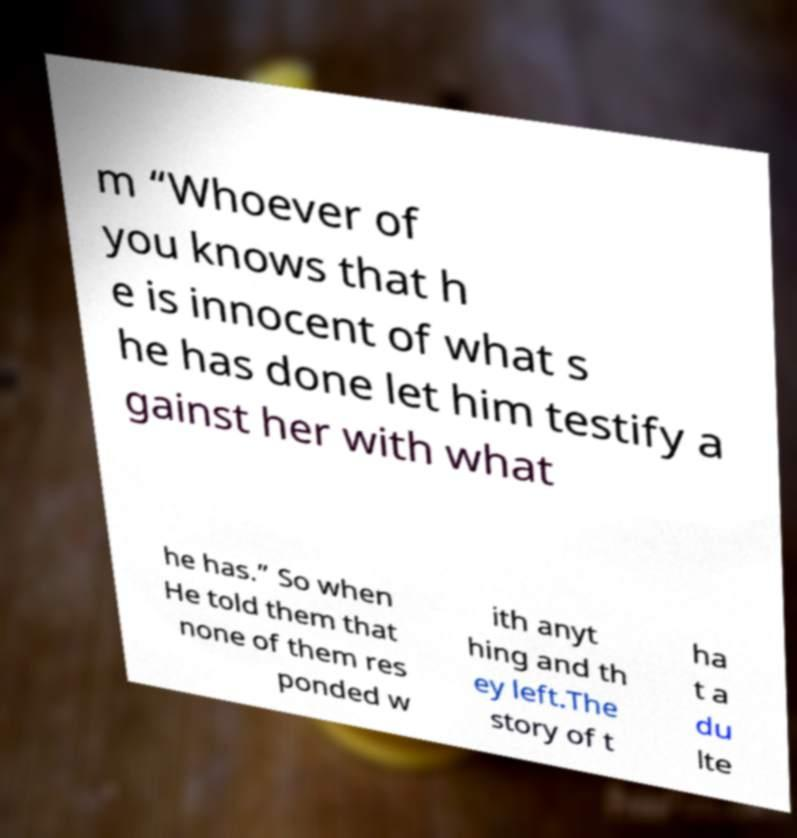There's text embedded in this image that I need extracted. Can you transcribe it verbatim? m “Whoever of you knows that h e is innocent of what s he has done let him testify a gainst her with what he has.” So when He told them that none of them res ponded w ith anyt hing and th ey left.The story of t ha t a du lte 